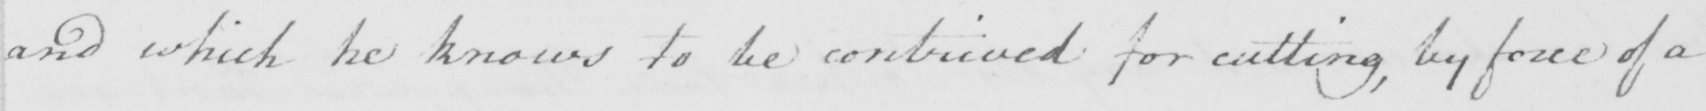Can you tell me what this handwritten text says? and which he knows to be contrived for cutting , by force of a 